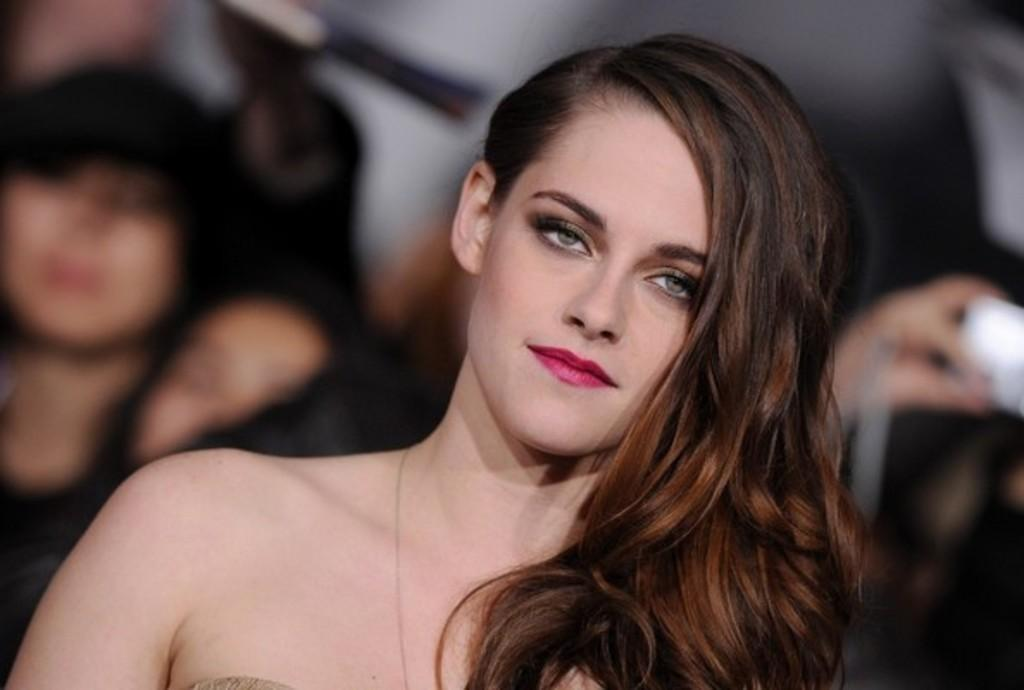Who is the main subject in the image? There is a woman in the image. Can you describe the surroundings of the woman? There are people in the background of the image. How would you describe the quality of the background in the image? The background of the image is slightly blurry. What type of tree is being selected in the image? There is no tree present in the image, and therefore no selection process is taking place. What game are the people in the background playing in the image? There is no game being played in the image; the people in the background are simply present. 